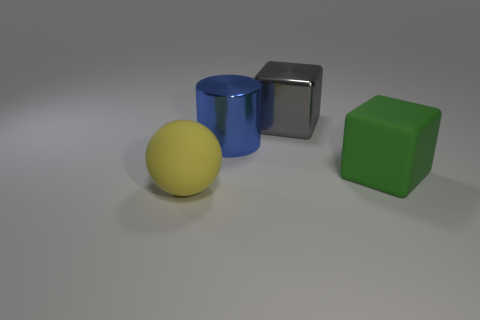Subtract all spheres. How many objects are left? 3 Subtract 1 cylinders. How many cylinders are left? 0 Subtract all green rubber cylinders. Subtract all gray shiny cubes. How many objects are left? 3 Add 3 big rubber blocks. How many big rubber blocks are left? 4 Add 3 big yellow matte objects. How many big yellow matte objects exist? 4 Add 2 matte things. How many objects exist? 6 Subtract all green cubes. How many cubes are left? 1 Subtract 0 yellow blocks. How many objects are left? 4 Subtract all green spheres. Subtract all yellow blocks. How many spheres are left? 1 Subtract all brown cylinders. How many gray cubes are left? 1 